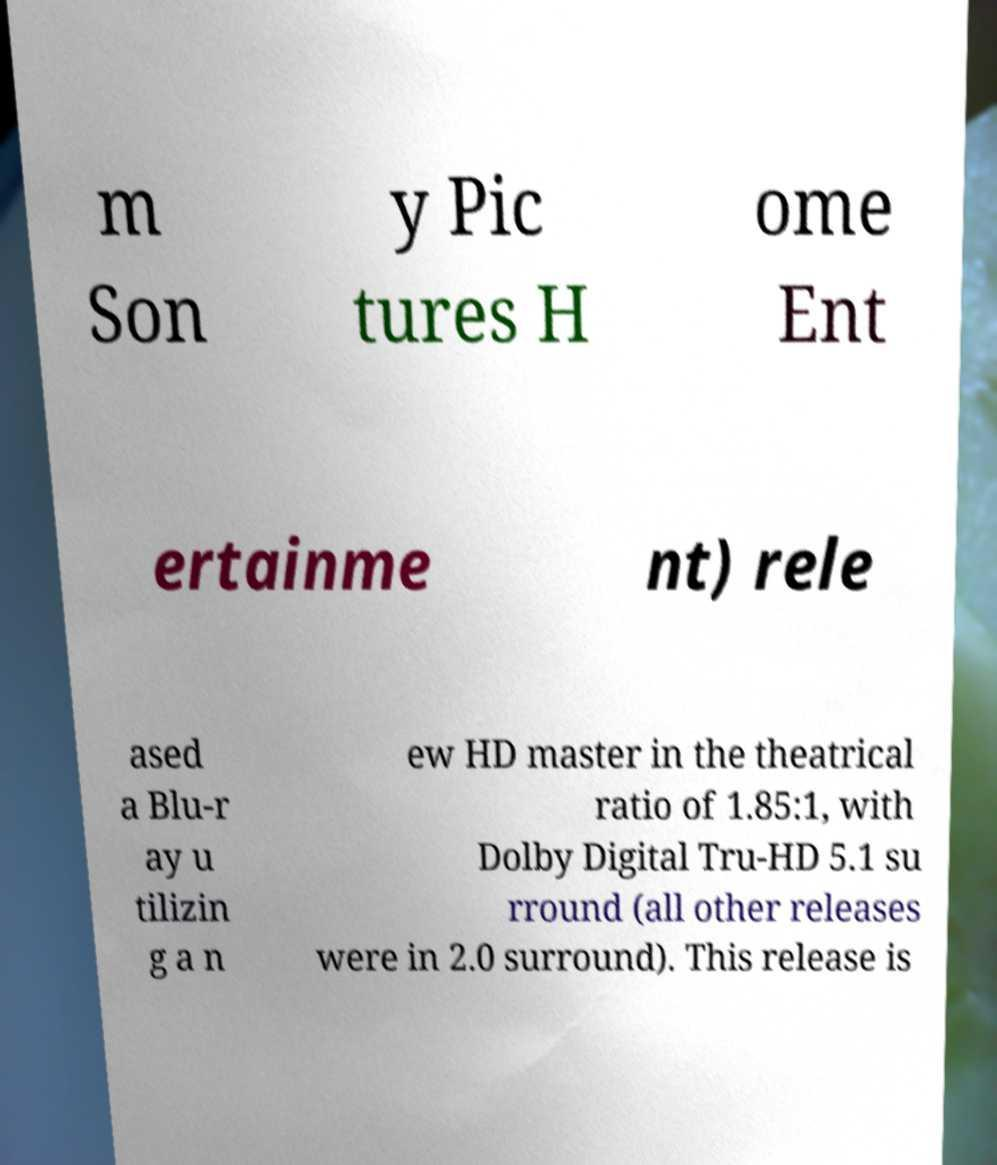I need the written content from this picture converted into text. Can you do that? m Son y Pic tures H ome Ent ertainme nt) rele ased a Blu-r ay u tilizin g a n ew HD master in the theatrical ratio of 1.85:1, with Dolby Digital Tru-HD 5.1 su rround (all other releases were in 2.0 surround). This release is 